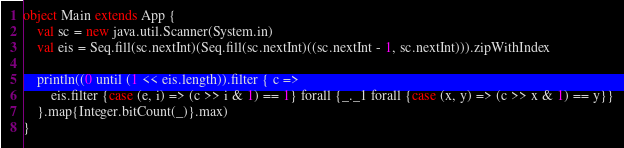Convert code to text. <code><loc_0><loc_0><loc_500><loc_500><_Scala_>object Main extends App {
	val sc = new java.util.Scanner(System.in)
	val eis = Seq.fill(sc.nextInt)(Seq.fill(sc.nextInt)((sc.nextInt - 1, sc.nextInt))).zipWithIndex
	
	println((0 until (1 << eis.length)).filter { c =>
		eis.filter {case (e, i) => (c >> i & 1) == 1} forall {_._1 forall {case (x, y) => (c >> x & 1) == y}}
	}.map{Integer.bitCount(_)}.max)
}</code> 